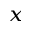<formula> <loc_0><loc_0><loc_500><loc_500>_ { x }</formula> 